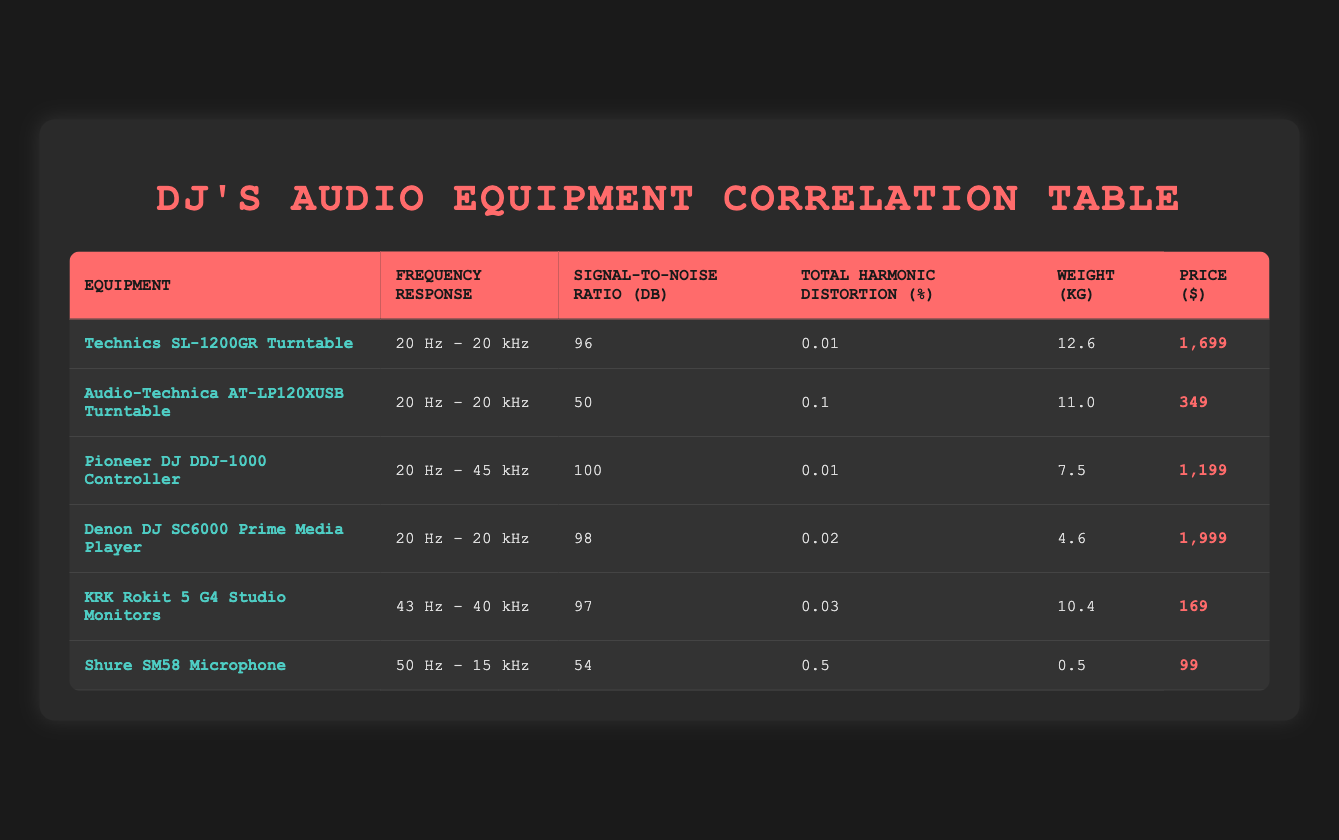What is the signal-to-noise ratio of the Technics SL-1200GR Turntable? The signal-to-noise ratio for the Technics SL-1200GR Turntable is listed in the table under the corresponding column, which shows 96 dB.
Answer: 96 dB Which equipment has the highest total harmonic distortion? In the table, the total harmonic distortion values are listed for each equipment. The highest value is sourced from the Shure SM58 Microphone, which shows a total harmonic distortion of 0.5%.
Answer: 0.5% What is the average weight of all the listed audio equipment? To find the average weight, sum the weights: 12.6 + 11.0 + 7.5 + 4.6 + 10.4 + 0.5 = 46.6 kg. Then divide by the number of equipment (6): 46.6 kg / 6 = 7.7667 kg, rounded to two decimal places is approximately 7.77 kg.
Answer: 7.77 kg Is the frequency response of the Pioneer DJ DDJ-1000 Controller wider than that of the Audio-Technica AT-LP120XUSB Turntable? The frequency response of the Pioneer DJ DDJ-1000 Controller is 20 Hz - 45 kHz while the Audio-Technica AT-LP120XUSB Turntable is 20 Hz - 20 kHz. Since 45 kHz is greater than 20 kHz, the Pioneer controller has a wider frequency range.
Answer: Yes How much more does the Denon DJ SC6000 Prime Media Player cost compared to the Audio-Technica AT-LP120XUSB Turntable? The price of the Denon DJ SC6000 Prime Media Player is $1999 and the Audio-Technica AT-LP120XUSB Turntable is $349. To find the difference, subtract the price of the Audio-Technica from the price of the Denon: 1999 - 349 = 1650.
Answer: 1650 Which equipment has the lowest price and what is it? Looking through the price column, the lowest price belongs to the Shure SM58 Microphone at $99. This is the only one with a value lower than the others.
Answer: $99 What is the total price of the top three most expensive audio equipment? The prices for the top three most expensive items are: $1999 (Denon DJ SC6000), $1699 (Technics SL-1200GR), and $1199 (Pioneer DJ DDJ-1000). Summing these gives: 1999 + 1699 + 1199 = 4897.
Answer: 4897 Is the KRK Rokit 5 G4 Studio Monitors heavier than the Shure SM58 Microphone? The weight of the KRK Rokit 5 G4 Studio Monitors is 10.4 kg and the Shure SM58 Microphone is 0.5 kg. Since 10.4 kg is greater than 0.5 kg, the KRK is indeed heavier.
Answer: Yes 